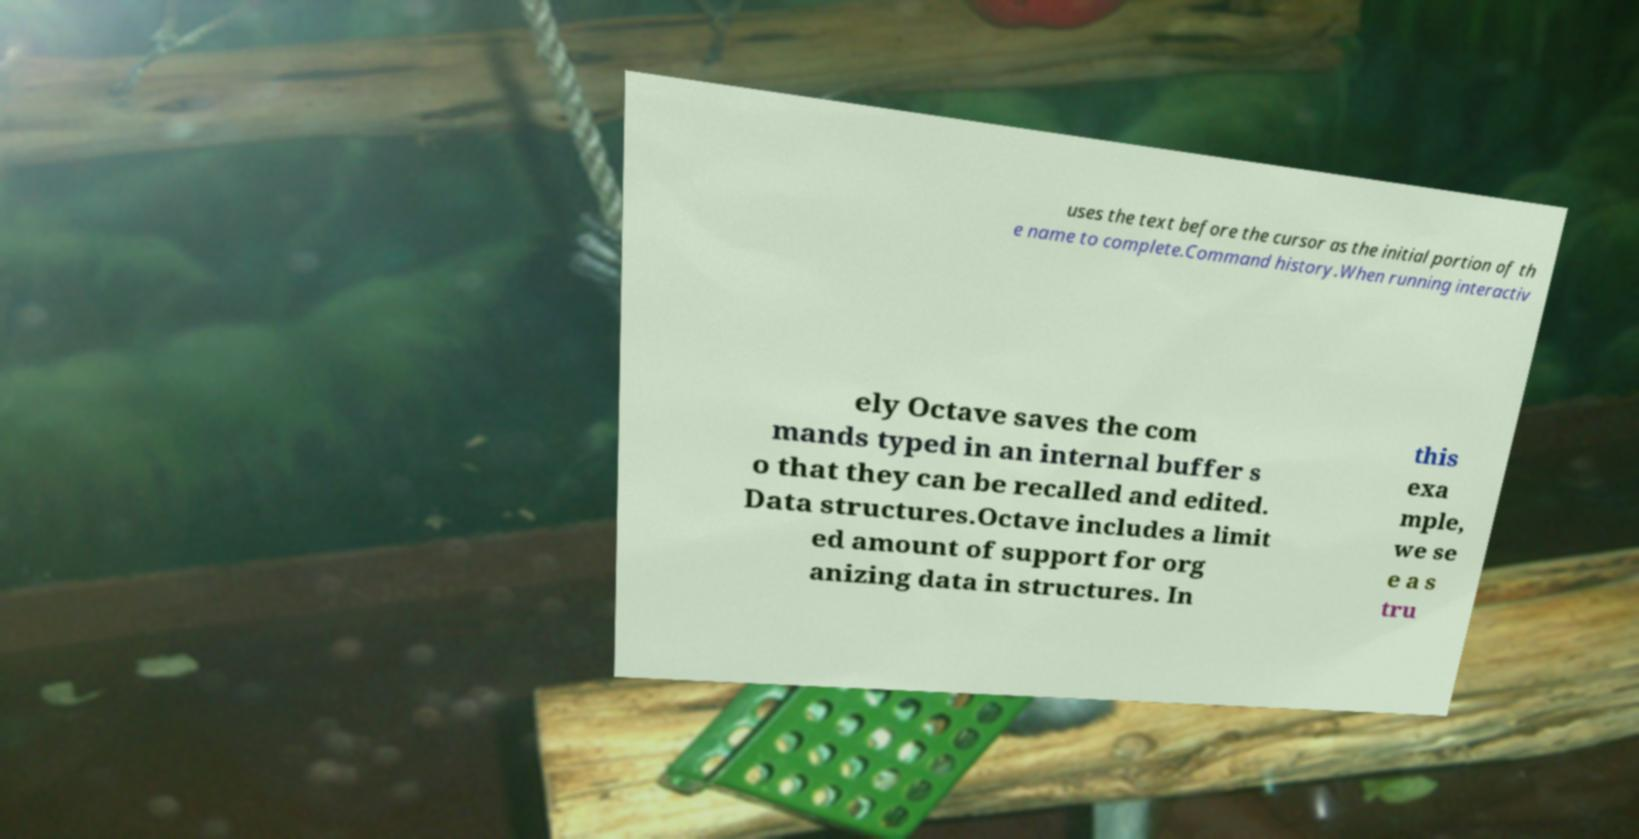I need the written content from this picture converted into text. Can you do that? uses the text before the cursor as the initial portion of th e name to complete.Command history.When running interactiv ely Octave saves the com mands typed in an internal buffer s o that they can be recalled and edited. Data structures.Octave includes a limit ed amount of support for org anizing data in structures. In this exa mple, we se e a s tru 